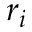<formula> <loc_0><loc_0><loc_500><loc_500>r _ { i }</formula> 